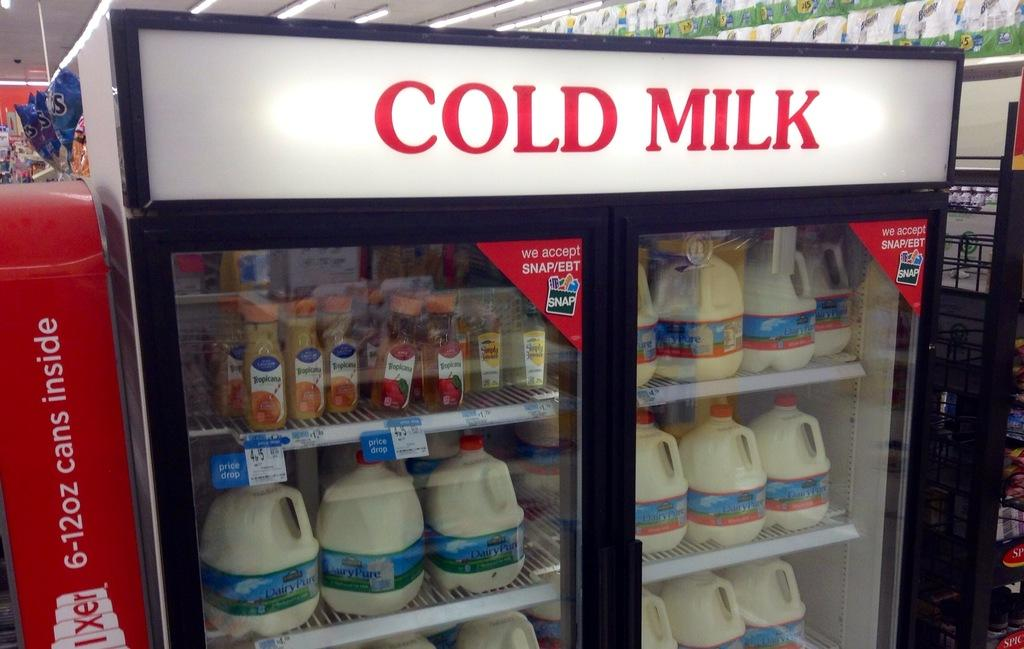<image>
Render a clear and concise summary of the photo. a display of COLD MILK with refrigerated items in a store 